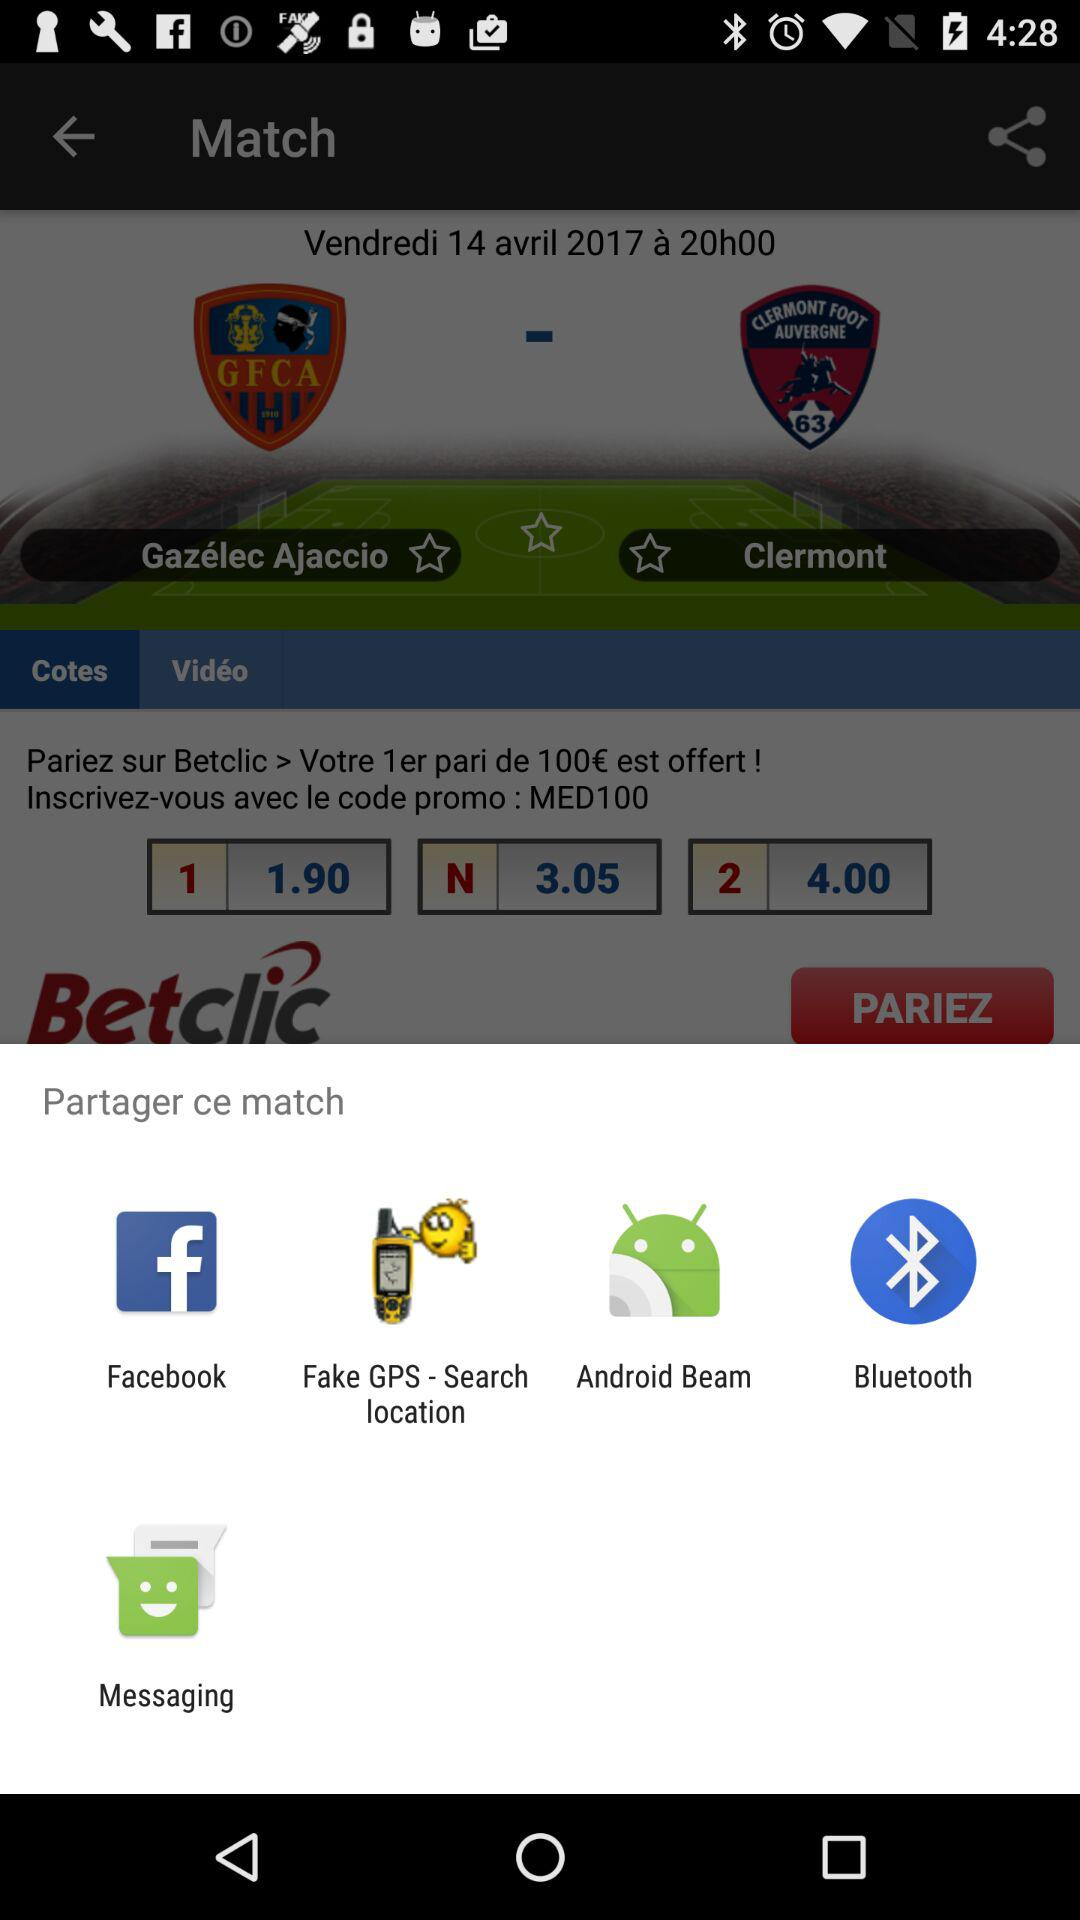Which app is available for sharing the match? The available apps are "Facebook", "Fake GPS - Search location", "Android Beam", "Bluetooth" and "Messaging". 